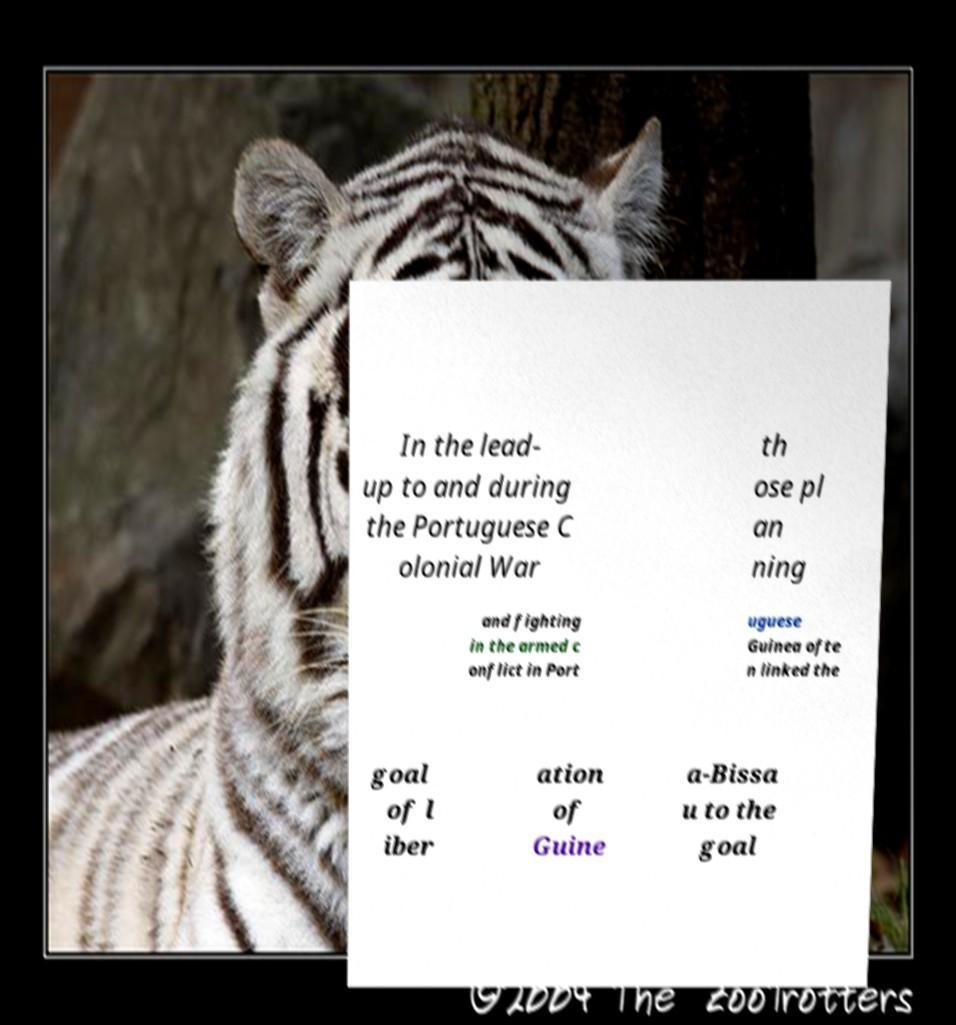Please read and relay the text visible in this image. What does it say? In the lead- up to and during the Portuguese C olonial War th ose pl an ning and fighting in the armed c onflict in Port uguese Guinea ofte n linked the goal of l iber ation of Guine a-Bissa u to the goal 